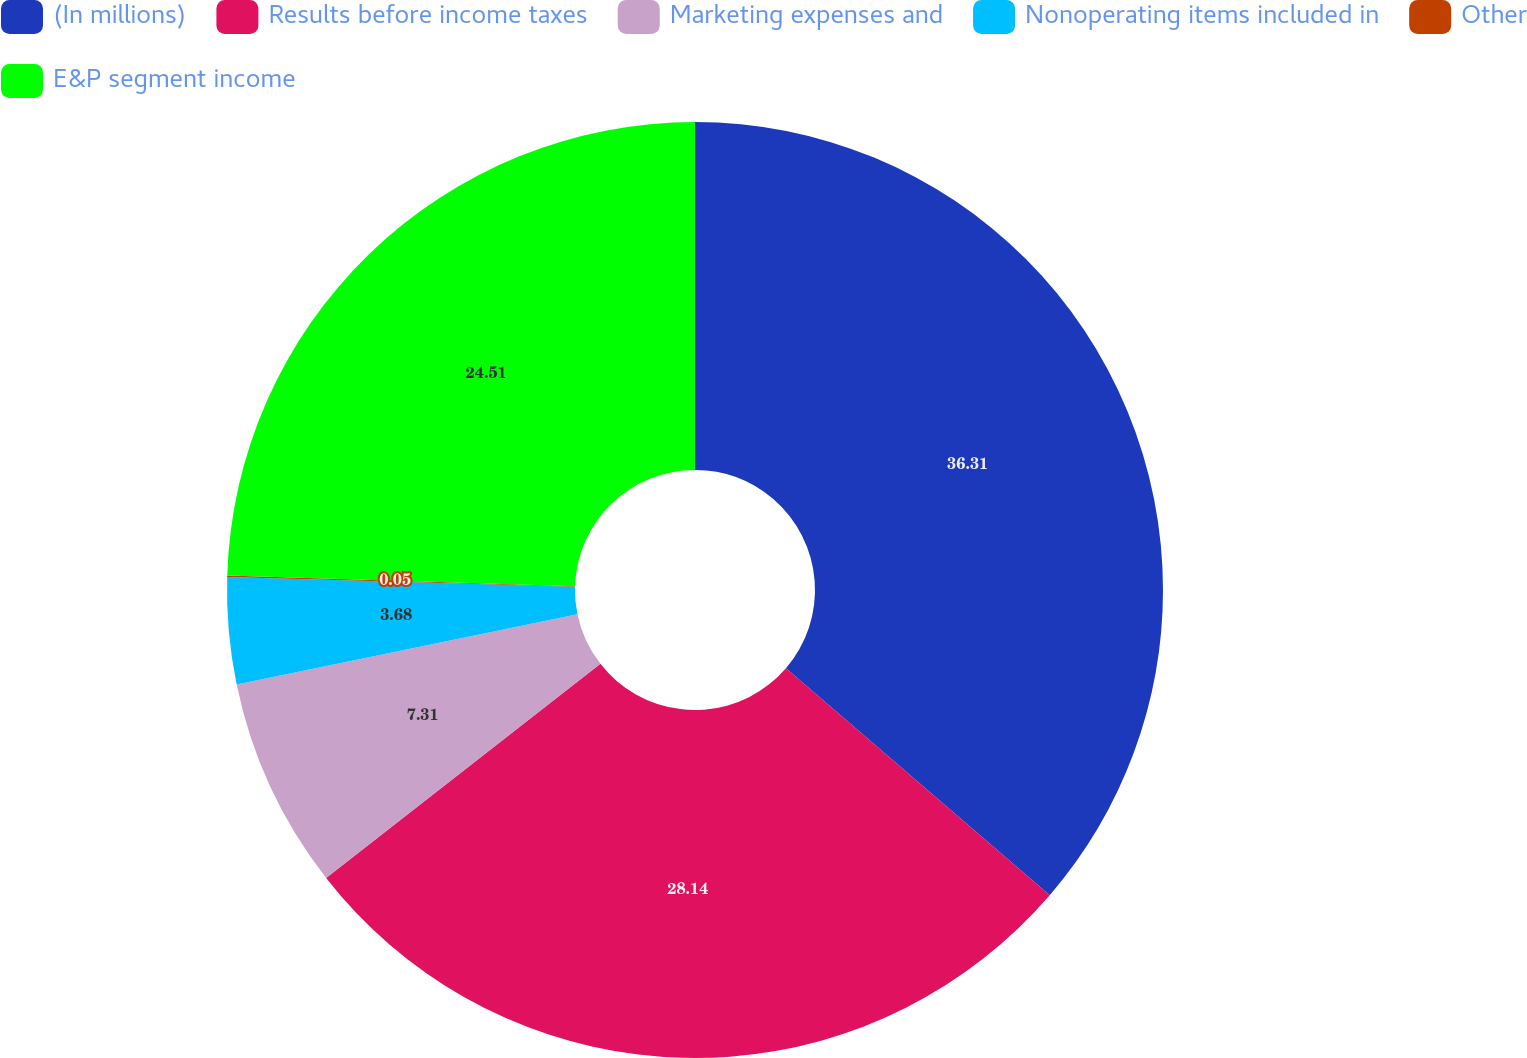<chart> <loc_0><loc_0><loc_500><loc_500><pie_chart><fcel>(In millions)<fcel>Results before income taxes<fcel>Marketing expenses and<fcel>Nonoperating items included in<fcel>Other<fcel>E&P segment income<nl><fcel>36.31%<fcel>28.14%<fcel>7.31%<fcel>3.68%<fcel>0.05%<fcel>24.51%<nl></chart> 